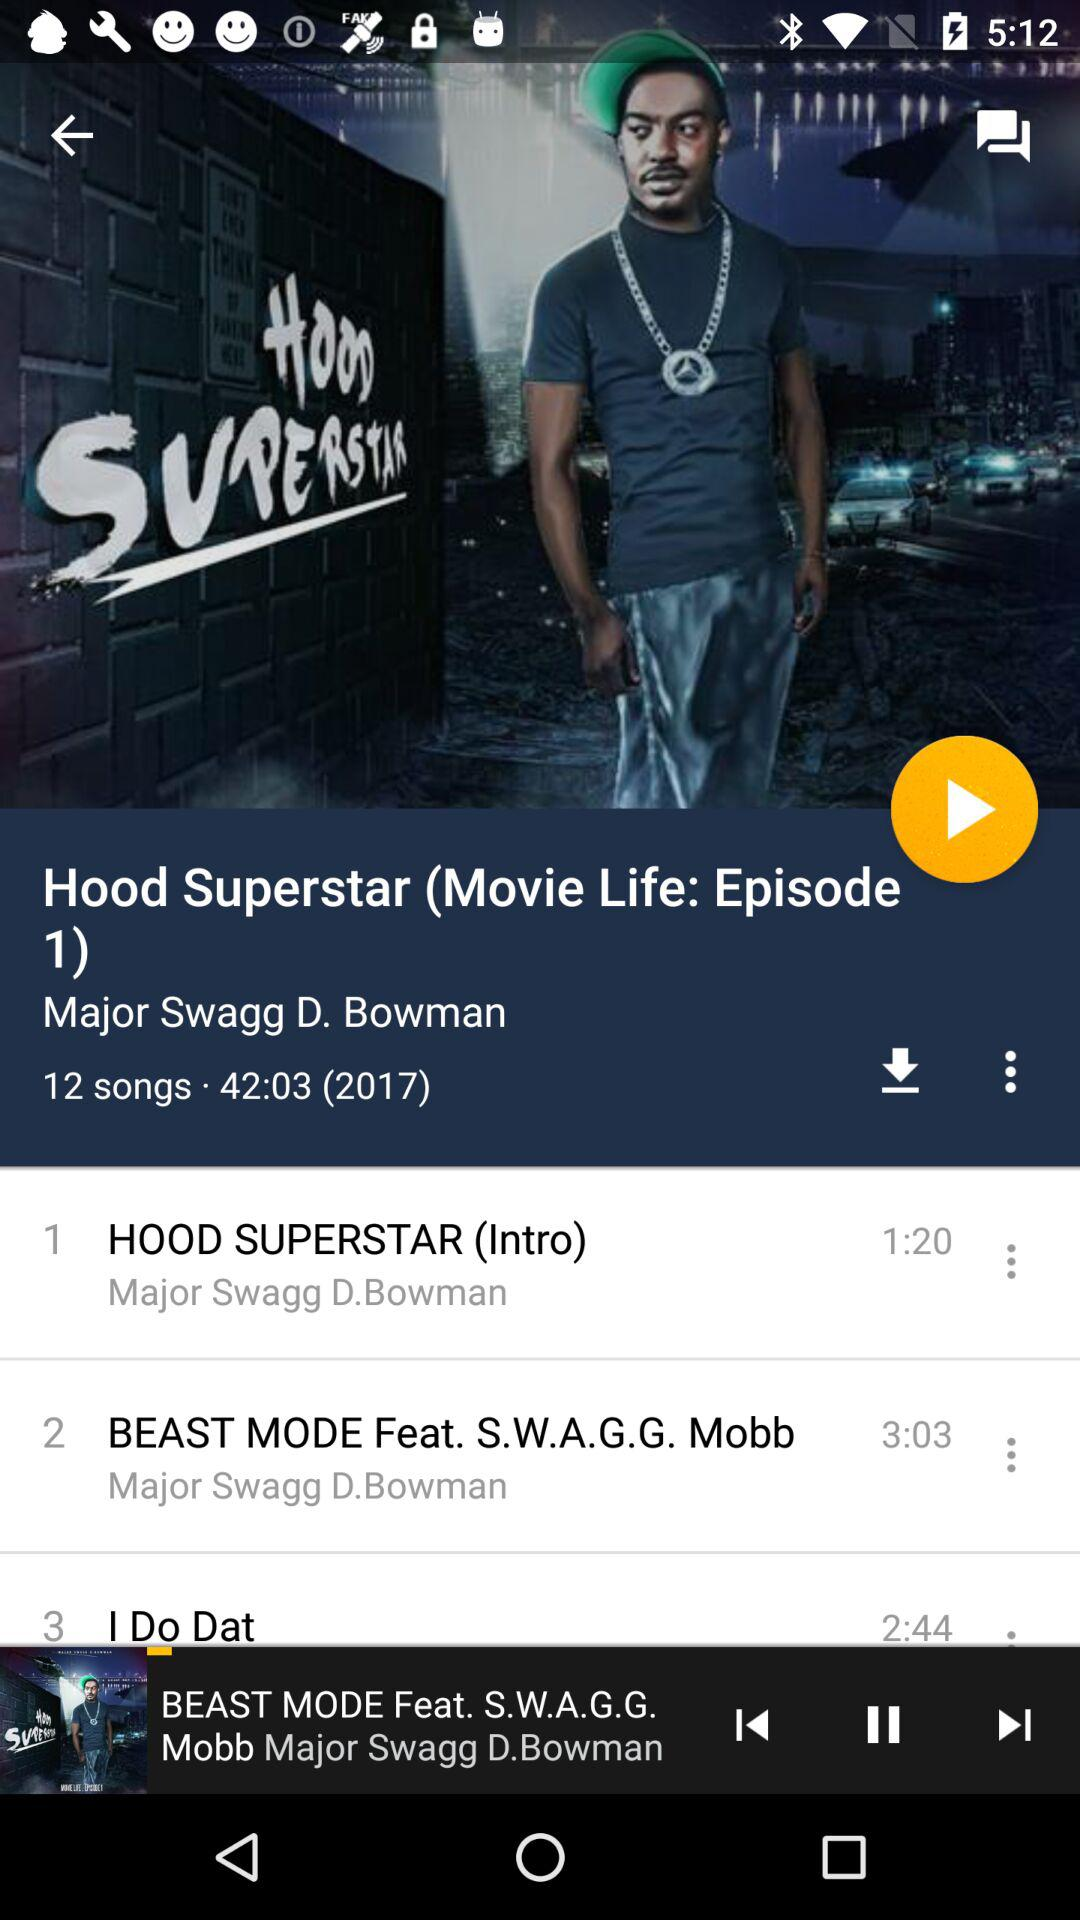Which episode is it? It is episode 1. 